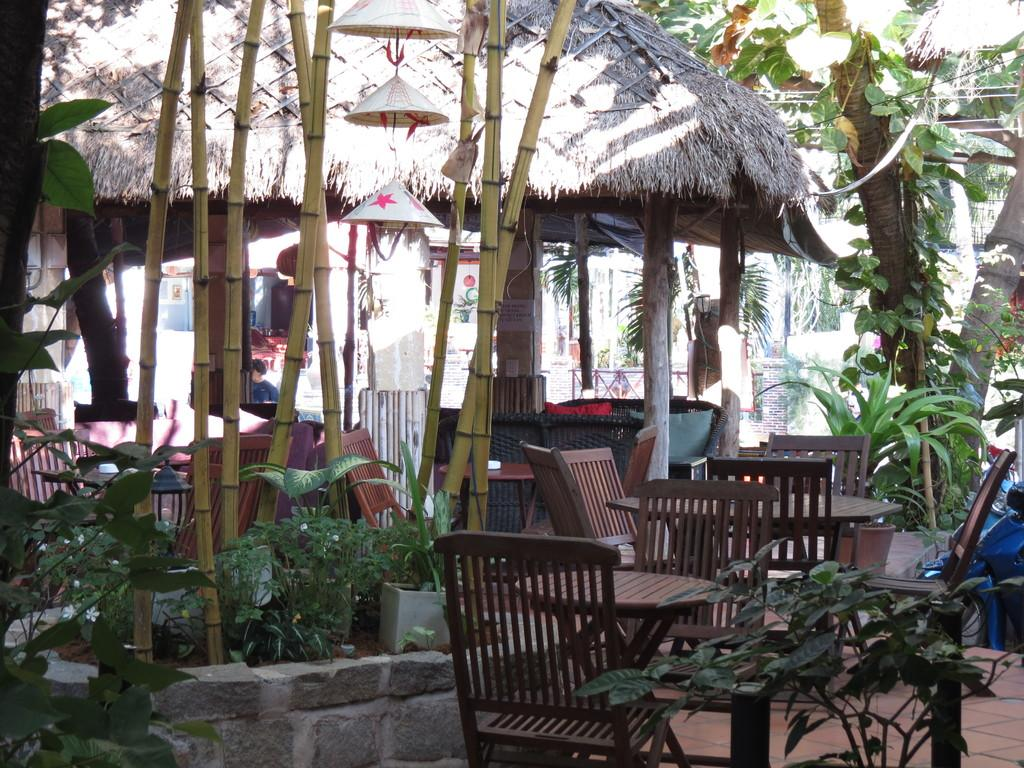What type of vegetation is at the bottom of the image? There are plants at the bottom of the image. What type of furniture is visible in the image? There are chairs and tables in the image. What structure is located in the middle of the image? There is a hut in the middle of the image. What type of natural scenery is visible behind the hut? There are trees behind the hut. How many years have the sisters been living in the hut in the image? There is no mention of sisters or any time-related information in the image. What type of home is depicted in the image? The image does not depict a home; it features a hut and other elements such as plants, chairs, tables, and trees. 